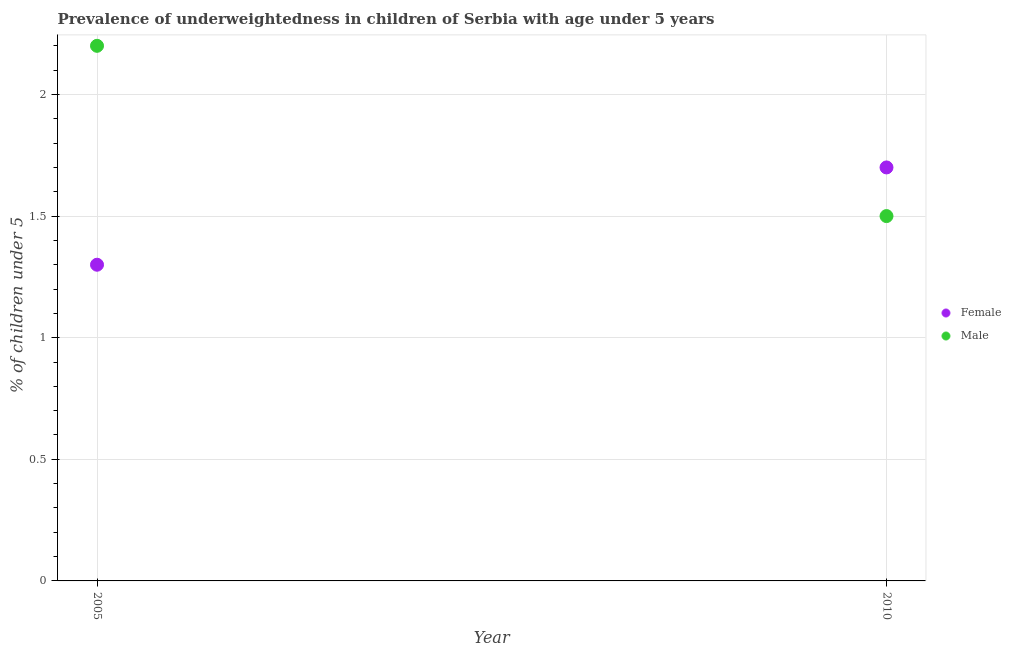Across all years, what is the maximum percentage of underweighted male children?
Your answer should be very brief. 2.2. Across all years, what is the minimum percentage of underweighted female children?
Keep it short and to the point. 1.3. In which year was the percentage of underweighted male children maximum?
Offer a terse response. 2005. What is the total percentage of underweighted female children in the graph?
Keep it short and to the point. 3. What is the difference between the percentage of underweighted female children in 2005 and that in 2010?
Your answer should be very brief. -0.4. What is the difference between the percentage of underweighted male children in 2010 and the percentage of underweighted female children in 2005?
Offer a terse response. 0.2. What is the average percentage of underweighted female children per year?
Offer a very short reply. 1.5. In the year 2010, what is the difference between the percentage of underweighted male children and percentage of underweighted female children?
Provide a succinct answer. -0.2. What is the ratio of the percentage of underweighted male children in 2005 to that in 2010?
Your response must be concise. 1.47. Is the percentage of underweighted male children strictly greater than the percentage of underweighted female children over the years?
Provide a succinct answer. No. Is the percentage of underweighted female children strictly less than the percentage of underweighted male children over the years?
Keep it short and to the point. No. How many dotlines are there?
Your answer should be very brief. 2. What is the difference between two consecutive major ticks on the Y-axis?
Keep it short and to the point. 0.5. How are the legend labels stacked?
Keep it short and to the point. Vertical. What is the title of the graph?
Your response must be concise. Prevalence of underweightedness in children of Serbia with age under 5 years. Does "Quasi money growth" appear as one of the legend labels in the graph?
Your answer should be very brief. No. What is the label or title of the Y-axis?
Your answer should be very brief.  % of children under 5. What is the  % of children under 5 in Female in 2005?
Ensure brevity in your answer.  1.3. What is the  % of children under 5 in Male in 2005?
Make the answer very short. 2.2. What is the  % of children under 5 of Female in 2010?
Provide a short and direct response. 1.7. Across all years, what is the maximum  % of children under 5 in Female?
Your answer should be compact. 1.7. Across all years, what is the maximum  % of children under 5 of Male?
Your answer should be very brief. 2.2. Across all years, what is the minimum  % of children under 5 in Female?
Offer a very short reply. 1.3. Across all years, what is the minimum  % of children under 5 of Male?
Your answer should be very brief. 1.5. What is the difference between the  % of children under 5 in Male in 2005 and that in 2010?
Offer a very short reply. 0.7. What is the difference between the  % of children under 5 in Female in 2005 and the  % of children under 5 in Male in 2010?
Keep it short and to the point. -0.2. What is the average  % of children under 5 in Female per year?
Keep it short and to the point. 1.5. What is the average  % of children under 5 of Male per year?
Provide a succinct answer. 1.85. In the year 2005, what is the difference between the  % of children under 5 in Female and  % of children under 5 in Male?
Provide a short and direct response. -0.9. What is the ratio of the  % of children under 5 in Female in 2005 to that in 2010?
Your response must be concise. 0.76. What is the ratio of the  % of children under 5 in Male in 2005 to that in 2010?
Your answer should be compact. 1.47. What is the difference between the highest and the lowest  % of children under 5 of Female?
Offer a very short reply. 0.4. 